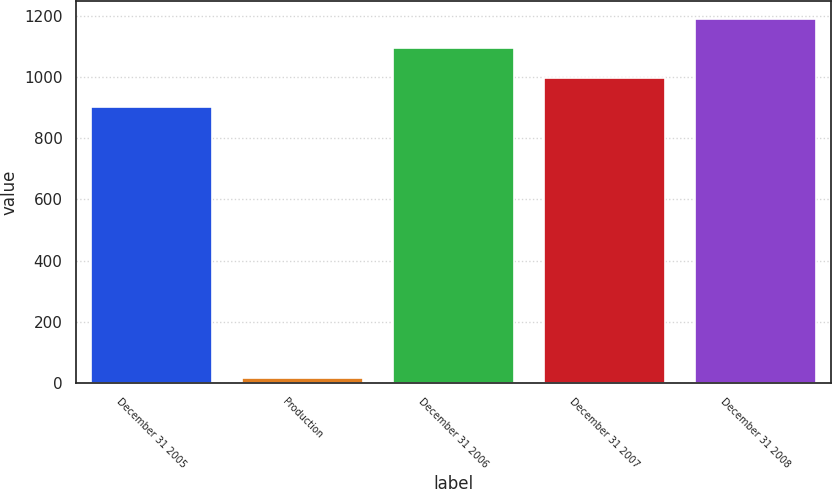Convert chart. <chart><loc_0><loc_0><loc_500><loc_500><bar_chart><fcel>December 31 2005<fcel>Production<fcel>December 31 2006<fcel>December 31 2007<fcel>December 31 2008<nl><fcel>901<fcel>17<fcel>1093.2<fcel>997.1<fcel>1189.3<nl></chart> 